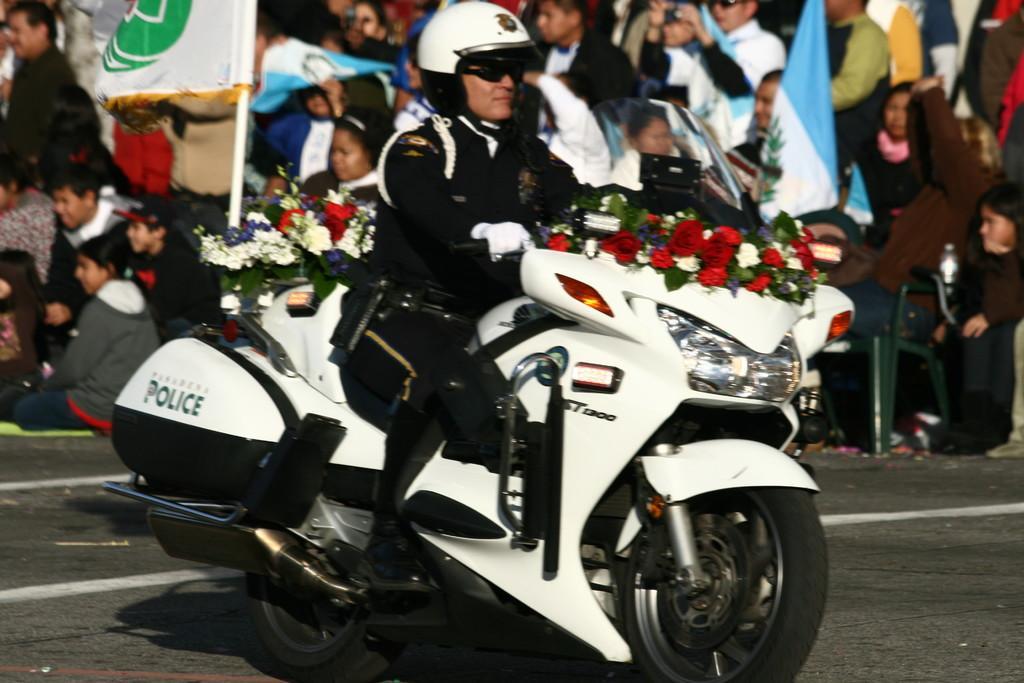Please provide a concise description of this image. In the middle there is a man he is riding bike. In the background there are many people and flag. 